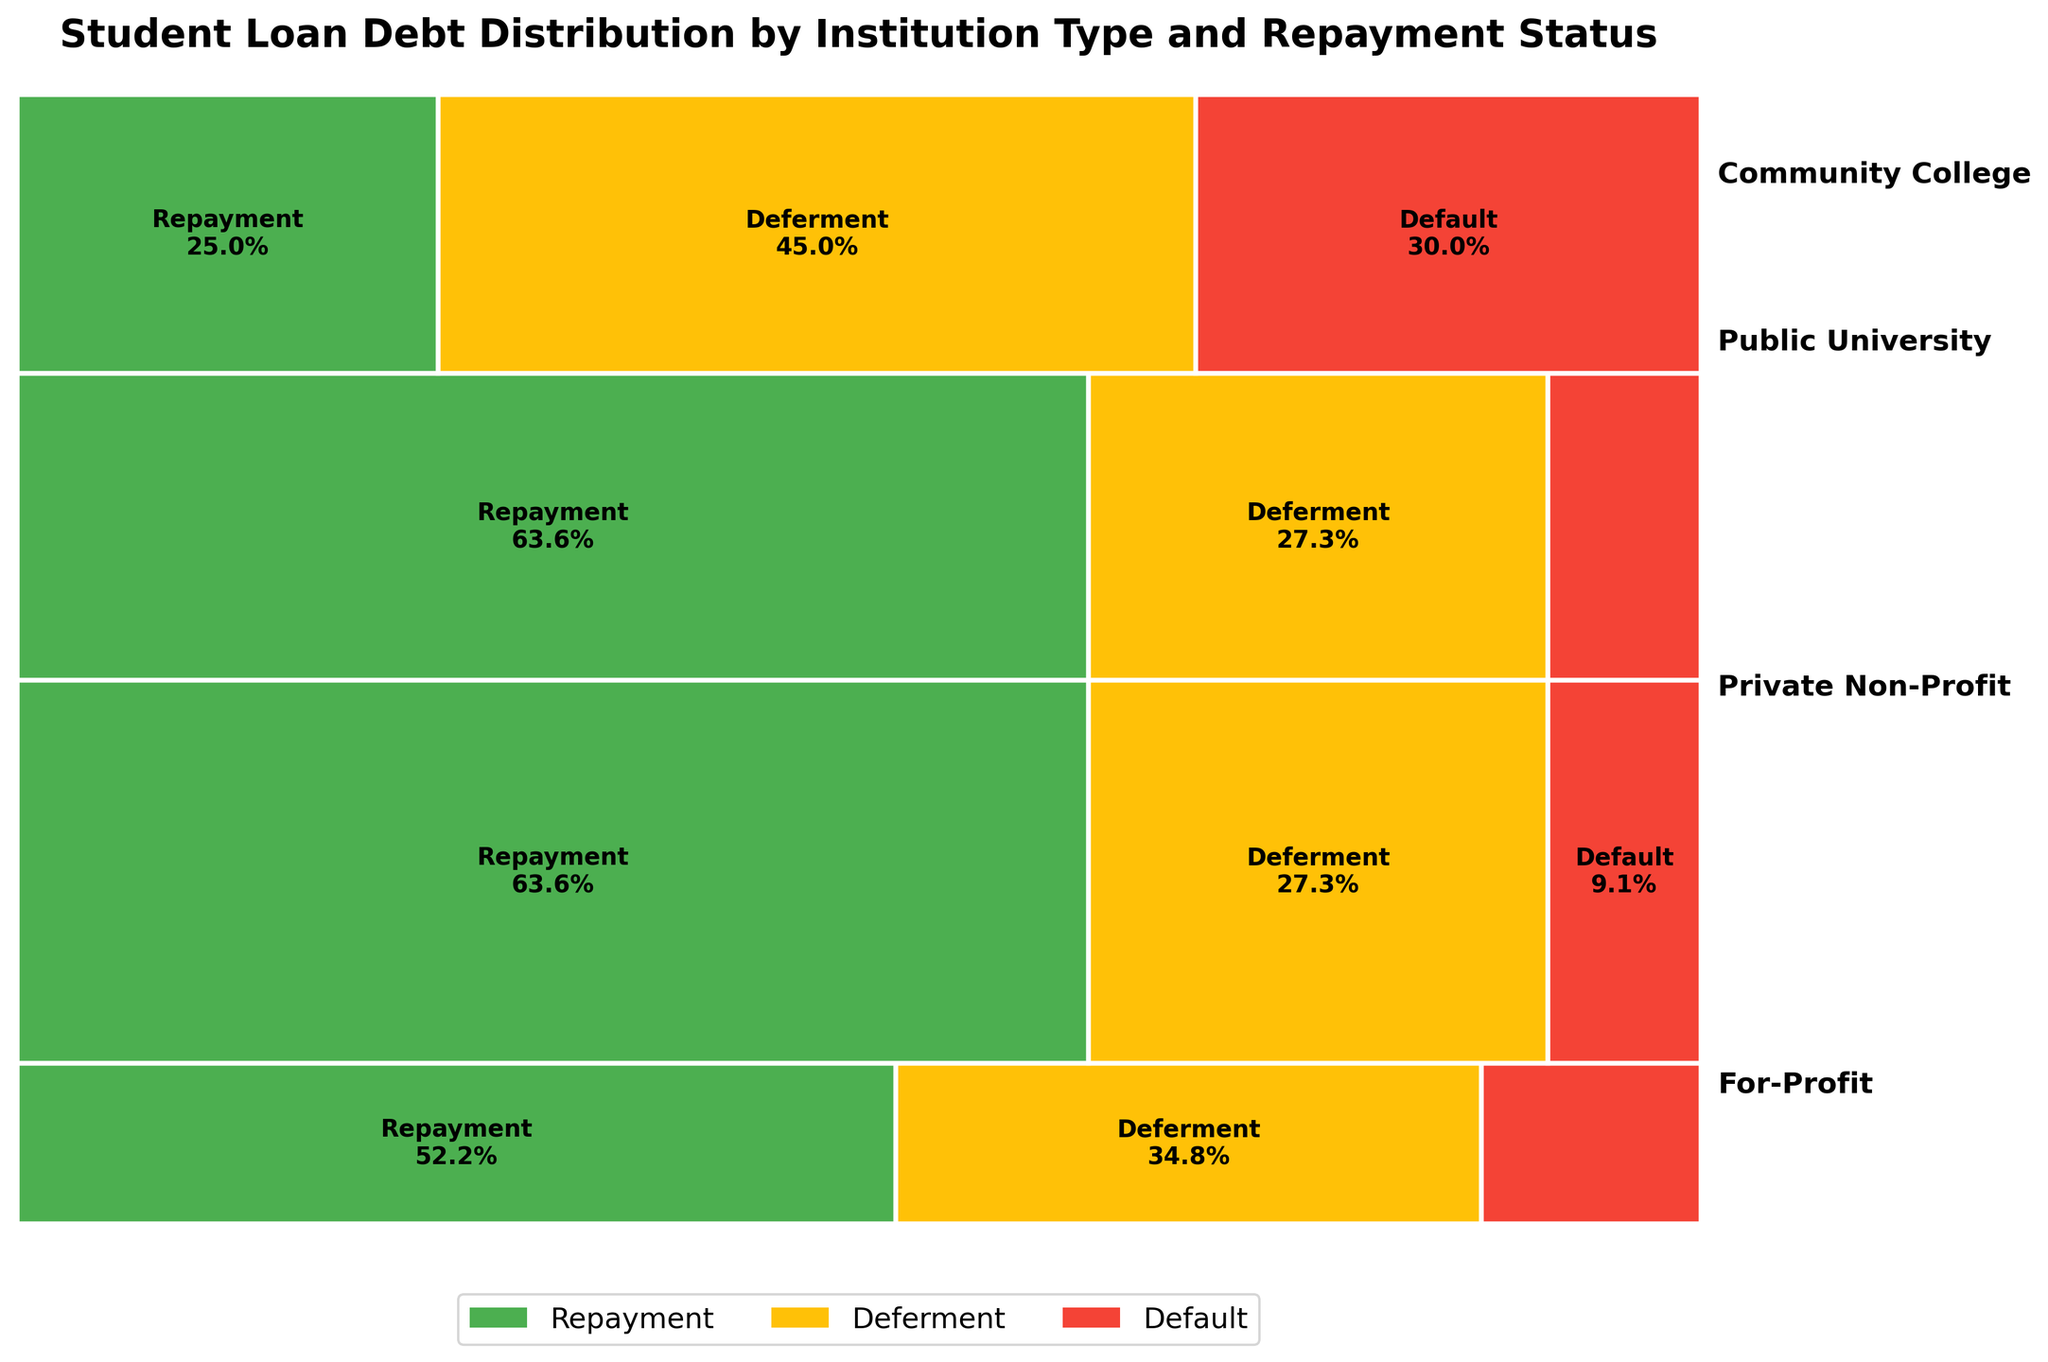What is the title of the plot? The title is the large, bold text usually found at the top of the plot, summarizing what the plot is showing.
Answer: "Student Loan Debt Distribution by Institution Type and Repayment Status" Which institution has the highest proportion of students in repayment status? By comparing the sizes of the green sections in each institution category, we can see that the Public University has the largest green section, indicating the highest proportion of students in repayment status.
Answer: Public University What is the overall color scheme used for different loan statuses? The plot uses three main colors: green for Repayment, yellow for Deferment, and red for Default. These colors are consistent across all institution types, aiding in differentiating loan statuses visually.
Answer: Green, Yellow, Red Which institution type has the highest proportion of loans in default status? By examining the red sections of the plot, we notice that the For-Profit institution has the largest red area, indicating the highest proportion of loans in default status.
Answer: For-Profit How does the proportion of students in default status compare between Community Colleges and Private Non-Profit institutions? To compare, look at the red sections for both Community Colleges and Private Non-Profit institutions. The red section of For-Profit is larger than that of Private Non-Profit, suggesting a higher proportion in default.
Answer: Higher in Community College What percentage of students in For-Profit institutions are in deferment status? The width of the yellow section in the For-Profit category represents the proportion of students in deferment status. This yellow section covers approximately 60% of the width for For-Profit.
Answer: 60% Between Community Colleges and Public Universities, which has a lower proportion of students in deferment status? By comparing the yellow sections of Community Colleges and Public Universities, we see that the yellow section for Community Colleges is relatively smaller.
Answer: Community Colleges What is the distribution of loan statuses for Community Colleges? The plot shows that for Community Colleges, the green (Repayment) section is about 48%, the yellow (Deferment) section is roughly 32%, and the red (Default) section is approximately 20%.
Answer: Repayment: 48%, Deferment: 32%, Default: 20% Which institution type has the smallest overall proportion of students? By comparing the total heights of the sections for each institution type, it is evident that the For-Profit category has the smallest total height, indicating the smallest overall proportion of students.
Answer: For-Profit 